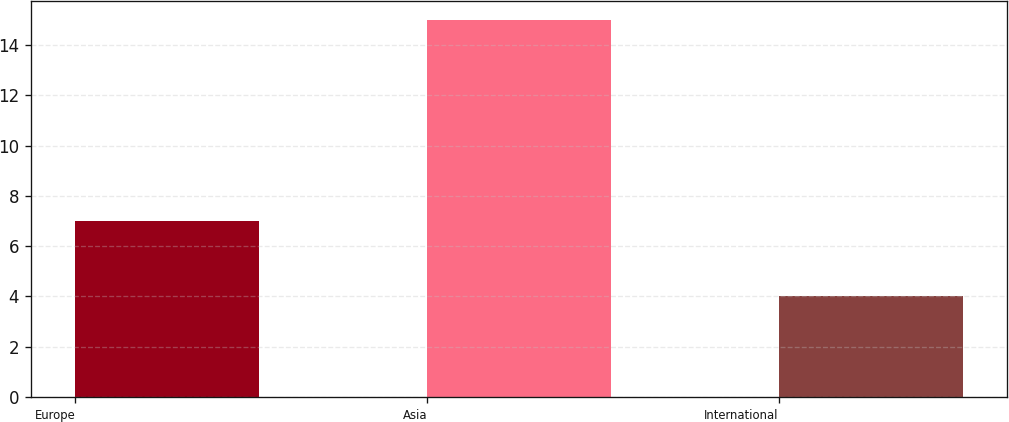<chart> <loc_0><loc_0><loc_500><loc_500><bar_chart><fcel>Europe<fcel>Asia<fcel>International<nl><fcel>7<fcel>15<fcel>4<nl></chart> 